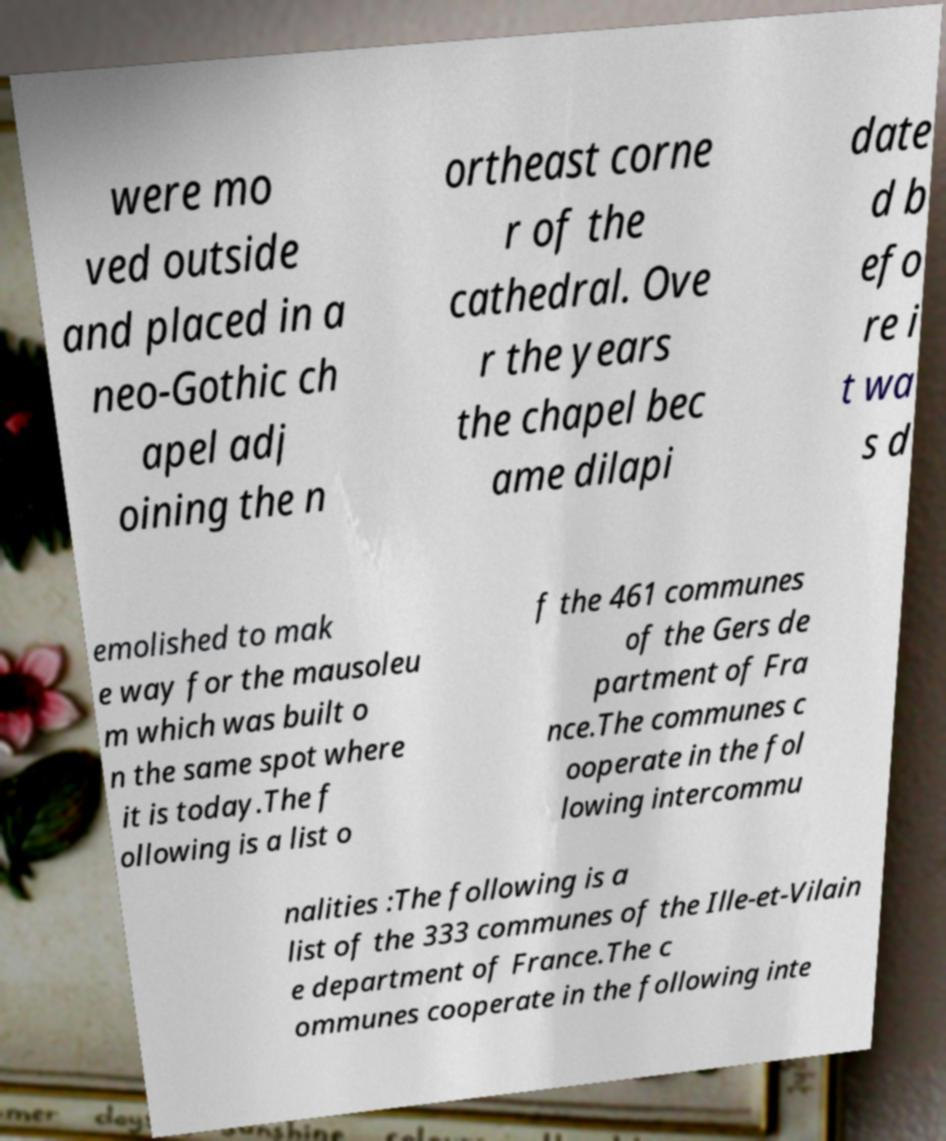There's text embedded in this image that I need extracted. Can you transcribe it verbatim? were mo ved outside and placed in a neo-Gothic ch apel adj oining the n ortheast corne r of the cathedral. Ove r the years the chapel bec ame dilapi date d b efo re i t wa s d emolished to mak e way for the mausoleu m which was built o n the same spot where it is today.The f ollowing is a list o f the 461 communes of the Gers de partment of Fra nce.The communes c ooperate in the fol lowing intercommu nalities :The following is a list of the 333 communes of the Ille-et-Vilain e department of France.The c ommunes cooperate in the following inte 